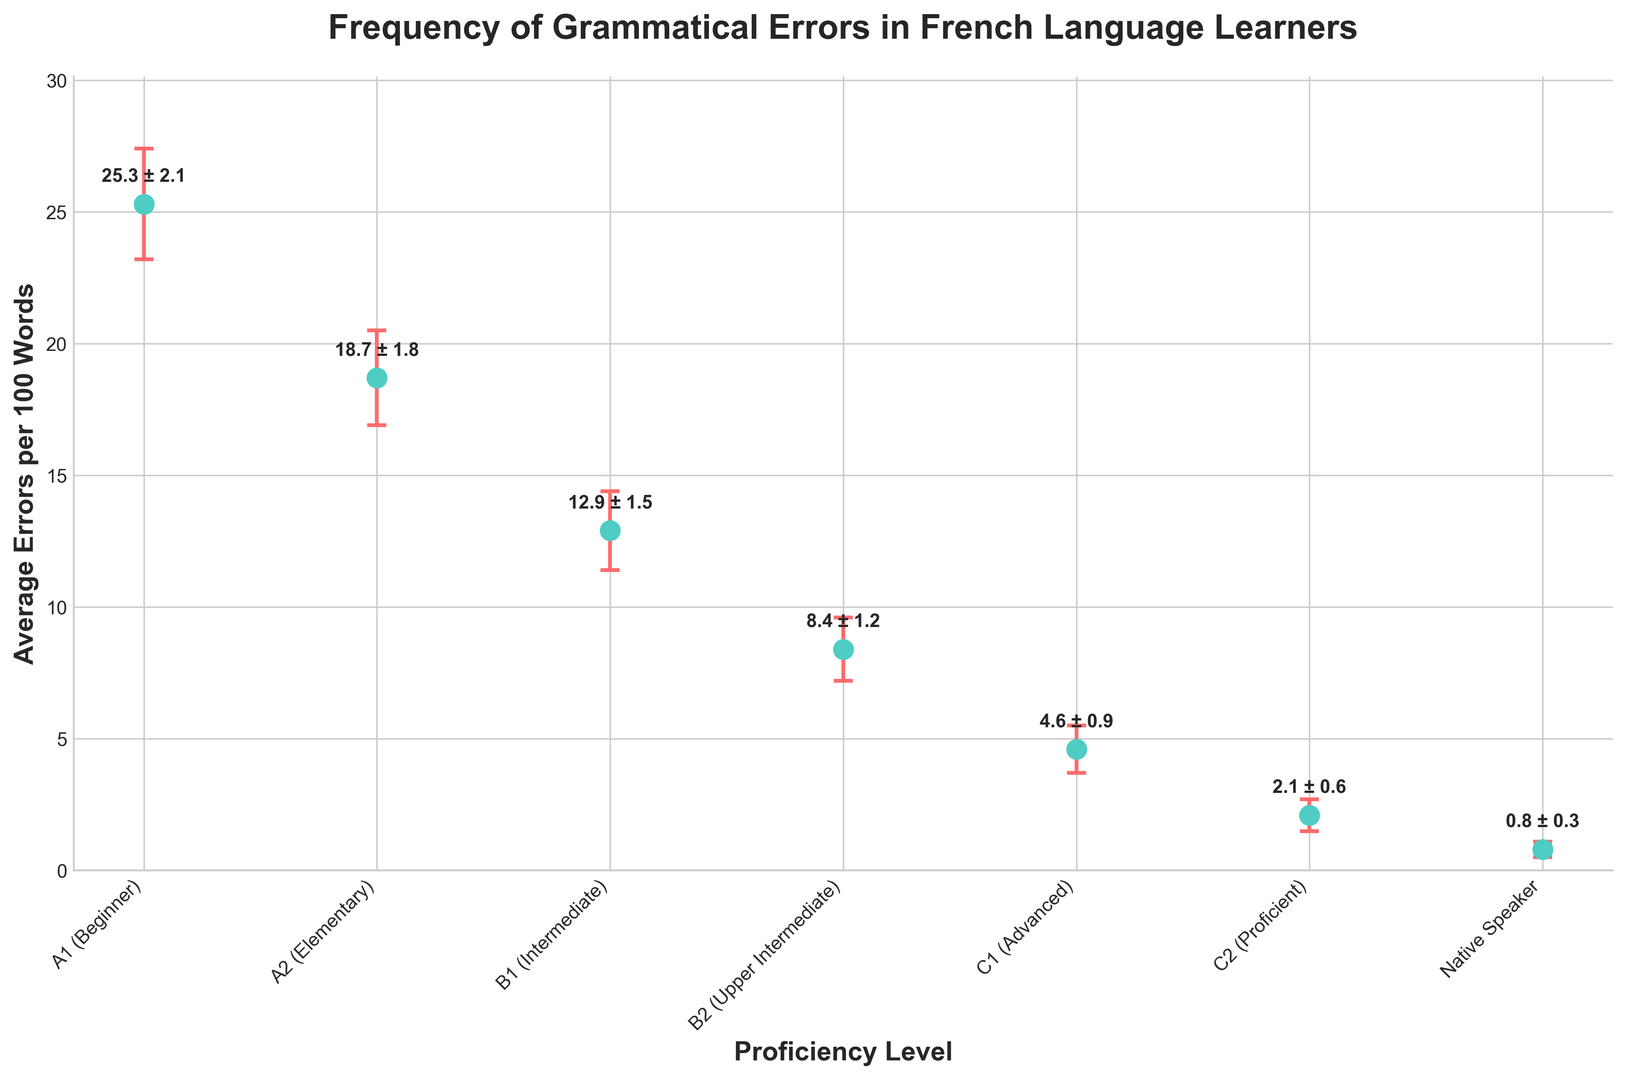What is the average number of grammatical errors per 100 words for B1 (Intermediate) learners? Locate the B1 (Intermediate) proficiency level on the x-axis and refer to the y-axis to find the corresponding value, which is 12.9 errors per 100 words.
Answer: 12.9 Which proficiency level has the highest average number of grammatical errors per 100 words? Look along the y-axis to identify the highest point and refer to the respective proficiency level. The highest point is for the A1 (Beginner) proficiency level, at 25.3 errors per 100 words.
Answer: A1 (Beginner) How does the average number of errors for C2 (Proficient) compare to that of C1 (Advanced)? Refer to the y-axis values at the C2 (Proficient) and C1 (Advanced) points. C2 learners have 2.1 errors per 100 words, while C1 learners have 4.6 errors per 100 words. C2 learners have fewer errors.
Answer: Fewer What is the difference in average grammatical errors per 100 words between A2 (Elementary) and Native Speakers? Find the values for both levels from the y-axis: A2 (Elementary) is at 18.7 errors and Native Speakers are at 0.8 errors. Subtract the smaller from the larger value (18.7 - 0.8).
Answer: 17.9 What is the sum of the average errors per 100 words for B2 (Upper Intermediate) and A1 (Beginner) learners? Identify the values for B2 (Upper Intermediate) and A1 (Beginner) from the y-axis: 8.4 and 25.3 respectively. Sum these values (8.4 + 25.3).
Answer: 33.7 Which proficiency level has the largest error margin in their average number of errors per 100 words? Compare the error margins shown by the error bars for each proficiency level. The largest error margin is for A1 (Beginner) at 2.1 errors.
Answer: A1 (Beginner) What is the relative decrease in average errors per 100 words from B2 (Upper Intermediate) to C1 (Advanced)? Find the values for B2 and C1 from the y-axis: 8.4 and 4.6 respectively. Calculate the decrease (8.4 - 4.6) and then divide by the initial value (8.4). ((8.4 - 4.6) / 8.4) = 0.4524, approximately 45%.
Answer: 45% Identify the range of average grammatical errors per 100 words across all proficiency levels. Find the highest value at A1 (Beginner): 25.3 errors, and the lowest value for Native Speakers: 0.8 errors. Subtract the lowest from the highest (25.3 - 0.8).
Answer: 24.5 